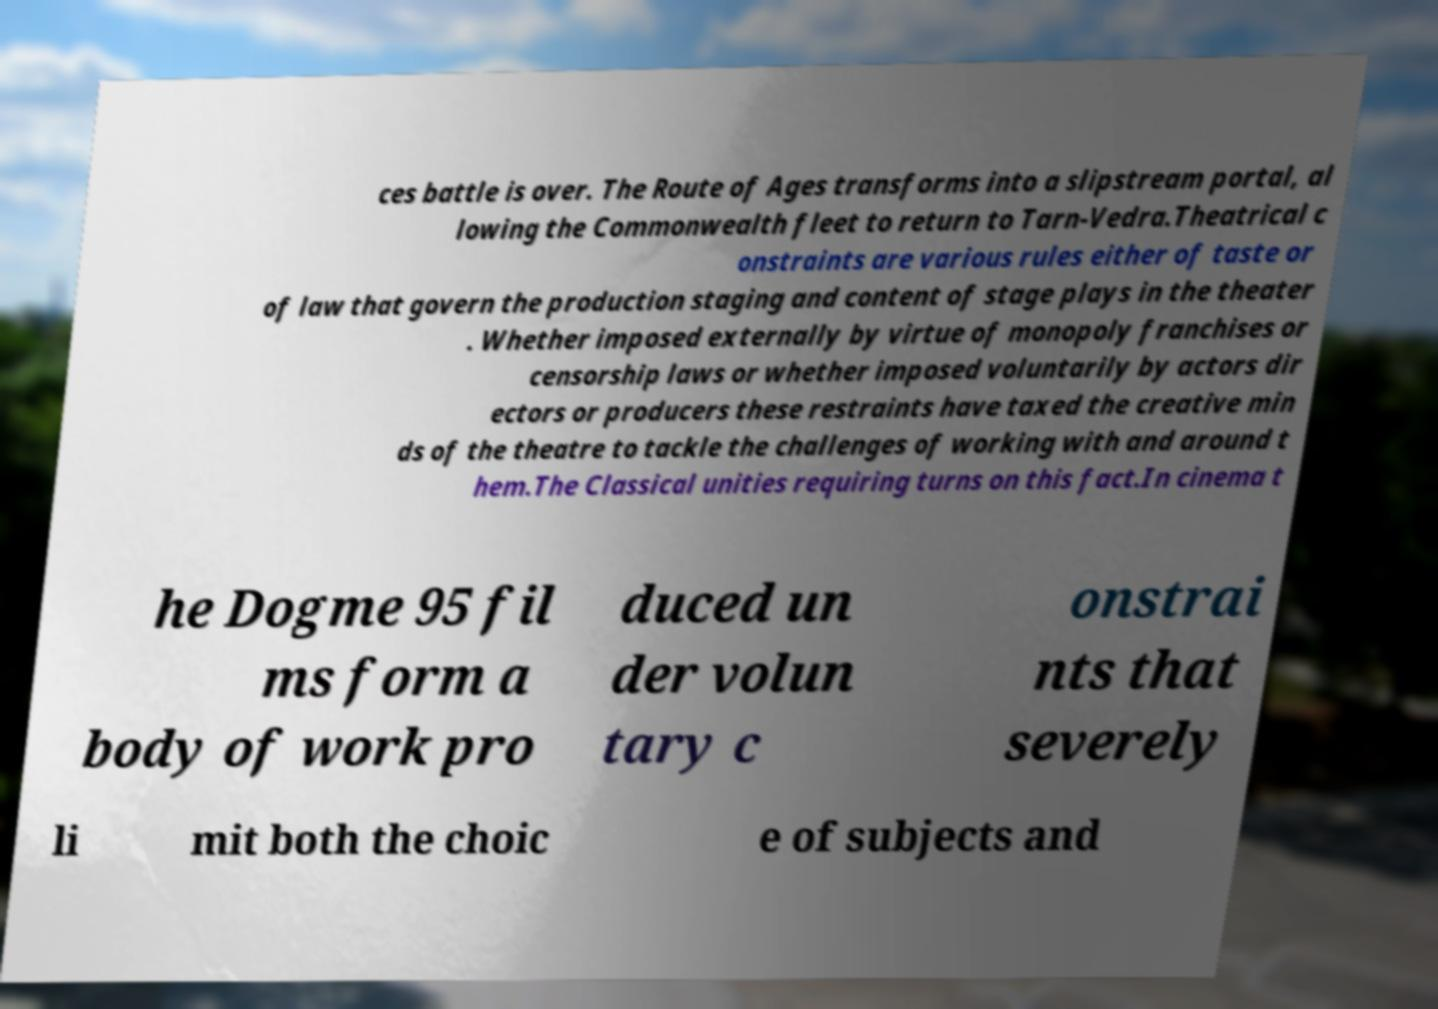Can you accurately transcribe the text from the provided image for me? ces battle is over. The Route of Ages transforms into a slipstream portal, al lowing the Commonwealth fleet to return to Tarn-Vedra.Theatrical c onstraints are various rules either of taste or of law that govern the production staging and content of stage plays in the theater . Whether imposed externally by virtue of monopoly franchises or censorship laws or whether imposed voluntarily by actors dir ectors or producers these restraints have taxed the creative min ds of the theatre to tackle the challenges of working with and around t hem.The Classical unities requiring turns on this fact.In cinema t he Dogme 95 fil ms form a body of work pro duced un der volun tary c onstrai nts that severely li mit both the choic e of subjects and 